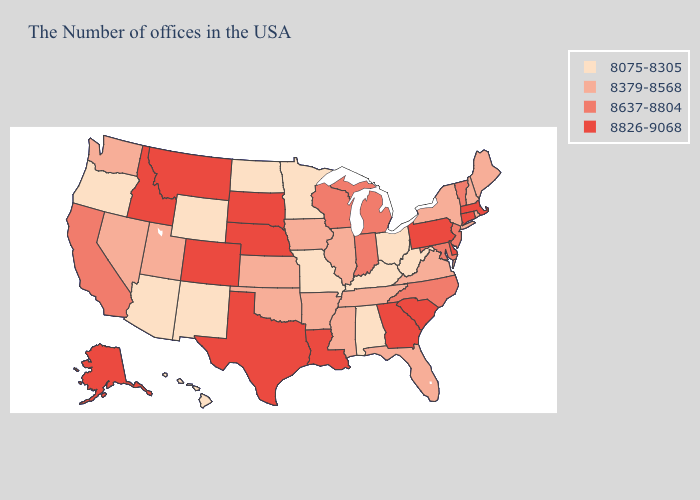What is the lowest value in states that border Rhode Island?
Give a very brief answer. 8826-9068. Does Kentucky have the lowest value in the South?
Concise answer only. Yes. Does the first symbol in the legend represent the smallest category?
Answer briefly. Yes. Among the states that border Nebraska , which have the lowest value?
Keep it brief. Missouri, Wyoming. Does the map have missing data?
Concise answer only. No. Is the legend a continuous bar?
Quick response, please. No. What is the highest value in the South ?
Concise answer only. 8826-9068. Is the legend a continuous bar?
Quick response, please. No. Name the states that have a value in the range 8826-9068?
Answer briefly. Massachusetts, Connecticut, Delaware, Pennsylvania, South Carolina, Georgia, Louisiana, Nebraska, Texas, South Dakota, Colorado, Montana, Idaho, Alaska. Name the states that have a value in the range 8637-8804?
Write a very short answer. Vermont, New Jersey, Maryland, North Carolina, Michigan, Indiana, Wisconsin, California. Does Oklahoma have the same value as Michigan?
Short answer required. No. What is the value of Virginia?
Concise answer only. 8379-8568. Name the states that have a value in the range 8379-8568?
Be succinct. Maine, Rhode Island, New Hampshire, New York, Virginia, Florida, Tennessee, Illinois, Mississippi, Arkansas, Iowa, Kansas, Oklahoma, Utah, Nevada, Washington. Name the states that have a value in the range 8826-9068?
Be succinct. Massachusetts, Connecticut, Delaware, Pennsylvania, South Carolina, Georgia, Louisiana, Nebraska, Texas, South Dakota, Colorado, Montana, Idaho, Alaska. Is the legend a continuous bar?
Answer briefly. No. 